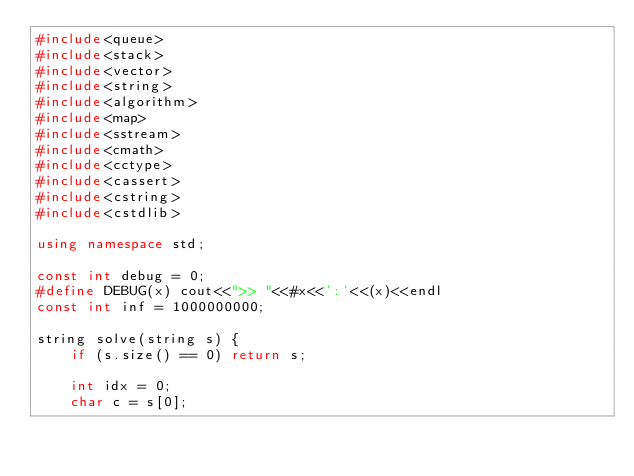<code> <loc_0><loc_0><loc_500><loc_500><_C++_>#include<queue>
#include<stack>
#include<vector>
#include<string>
#include<algorithm>
#include<map>
#include<sstream>
#include<cmath>
#include<cctype>
#include<cassert>
#include<cstring>
#include<cstdlib>

using namespace std;

const int debug = 0;
#define DEBUG(x) cout<<">> "<<#x<<':'<<(x)<<endl
const int inf = 1000000000;

string solve(string s) {
	if (s.size() == 0) return s;

	int idx = 0;
	char c = s[0];</code> 